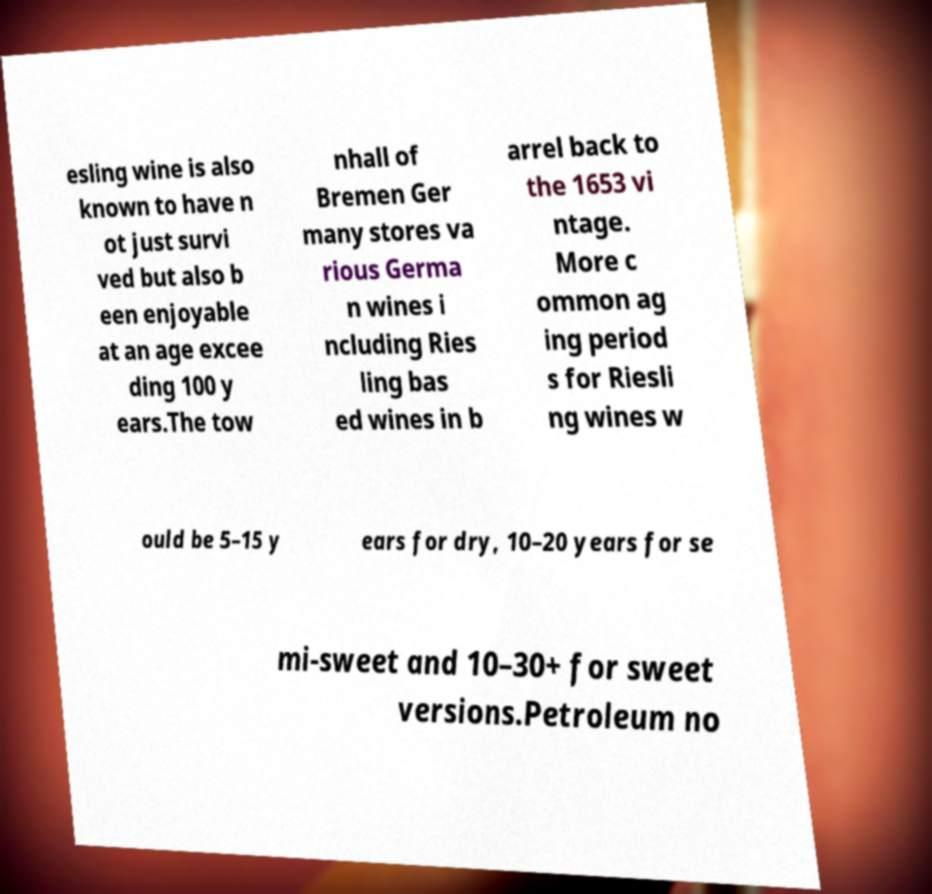Please read and relay the text visible in this image. What does it say? esling wine is also known to have n ot just survi ved but also b een enjoyable at an age excee ding 100 y ears.The tow nhall of Bremen Ger many stores va rious Germa n wines i ncluding Ries ling bas ed wines in b arrel back to the 1653 vi ntage. More c ommon ag ing period s for Riesli ng wines w ould be 5–15 y ears for dry, 10–20 years for se mi-sweet and 10–30+ for sweet versions.Petroleum no 